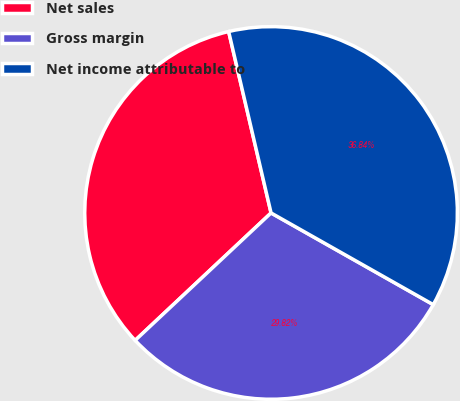<chart> <loc_0><loc_0><loc_500><loc_500><pie_chart><fcel>Net sales<fcel>Gross margin<fcel>Net income attributable to<nl><fcel>33.33%<fcel>29.82%<fcel>36.84%<nl></chart> 